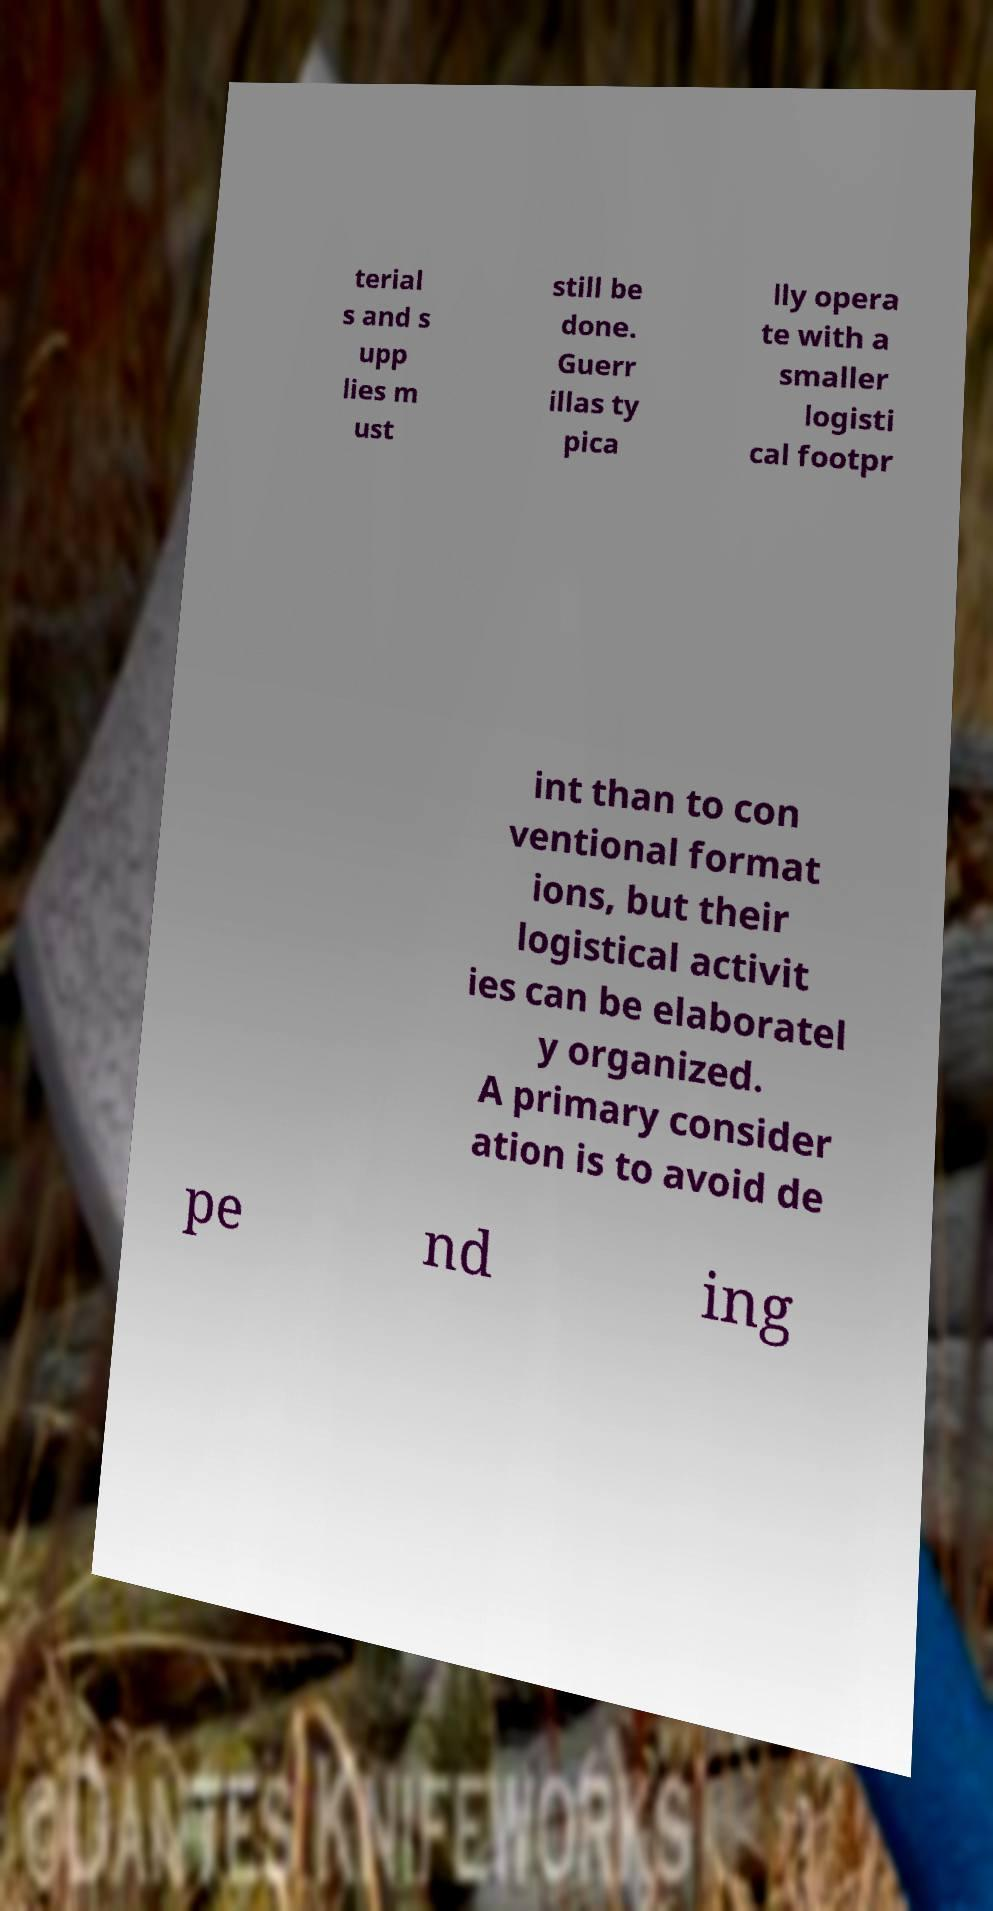For documentation purposes, I need the text within this image transcribed. Could you provide that? terial s and s upp lies m ust still be done. Guerr illas ty pica lly opera te with a smaller logisti cal footpr int than to con ventional format ions, but their logistical activit ies can be elaboratel y organized. A primary consider ation is to avoid de pe nd ing 